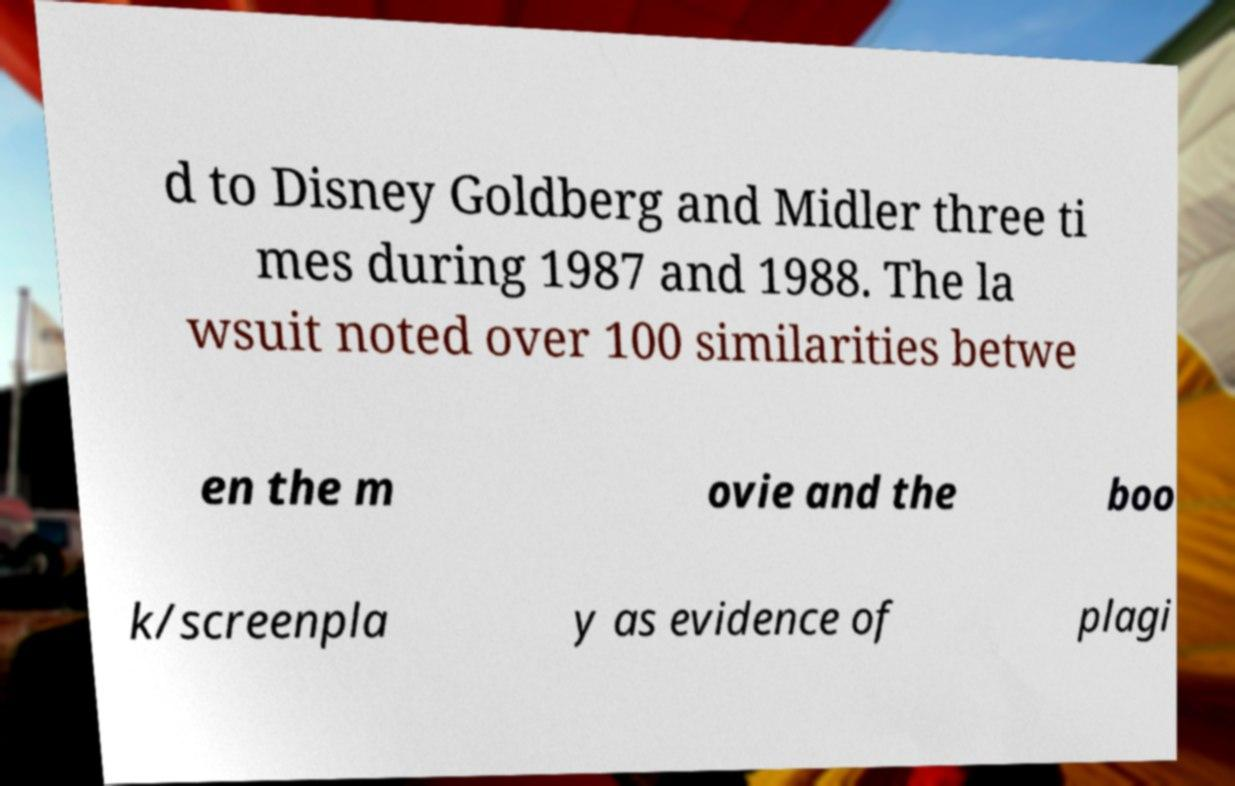For documentation purposes, I need the text within this image transcribed. Could you provide that? d to Disney Goldberg and Midler three ti mes during 1987 and 1988. The la wsuit noted over 100 similarities betwe en the m ovie and the boo k/screenpla y as evidence of plagi 